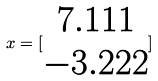Convert formula to latex. <formula><loc_0><loc_0><loc_500><loc_500>x = [ \begin{matrix} 7 . 1 1 1 \\ - 3 . 2 2 2 \end{matrix} ]</formula> 